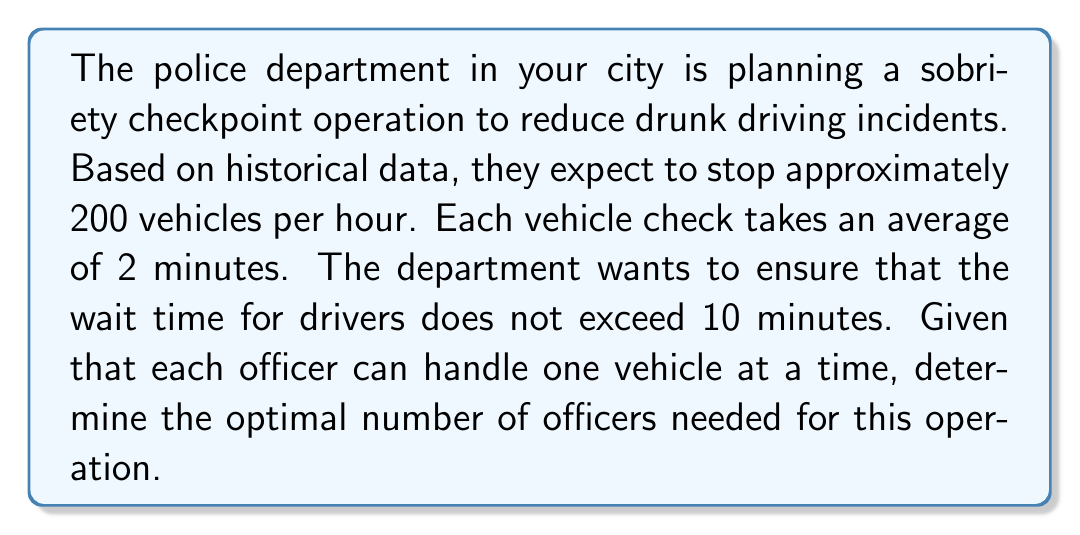Solve this math problem. To solve this optimization problem, we need to follow these steps:

1. Calculate the number of vehicles that can be processed per hour:
   Each check takes 2 minutes, so in one hour, an officer can process:
   $$ \text{Vehicles per officer per hour} = \frac{60 \text{ minutes}}{2 \text{ minutes/vehicle}} = 30 \text{ vehicles} $$

2. Calculate the total number of vehicle-minutes that need to be processed per hour:
   $$ \text{Total vehicle-minutes} = 200 \text{ vehicles} \times 2 \text{ minutes/vehicle} = 400 \text{ vehicle-minutes} $$

3. Calculate the number of officers needed to process all vehicles without any wait time:
   $$ \text{Officers for no wait} = \frac{400 \text{ vehicle-minutes}}{60 \text{ minutes}} \approx 6.67 \text{ officers} $$

4. However, we can allow for some wait time. The maximum acceptable wait time is 10 minutes. This means that the total processing time (wait + check) should not exceed 12 minutes per vehicle.

5. Calculate the effective processing rate with wait time:
   $$ \text{Effective rate} = \frac{200 \text{ vehicles}}{12 \text{ minutes}} \approx 16.67 \text{ vehicles/minute} $$

6. Calculate the number of officers needed to maintain this rate:
   $$ \text{Optimal number of officers} = \frac{16.67 \text{ vehicles/minute}}{0.5 \text{ vehicles/minute/officer}} \approx 33.33 $$

7. Round up to the nearest whole number, as we can't have a fractional number of officers.
Answer: The optimal number of officers needed for the sobriety checkpoint operation is 34. 